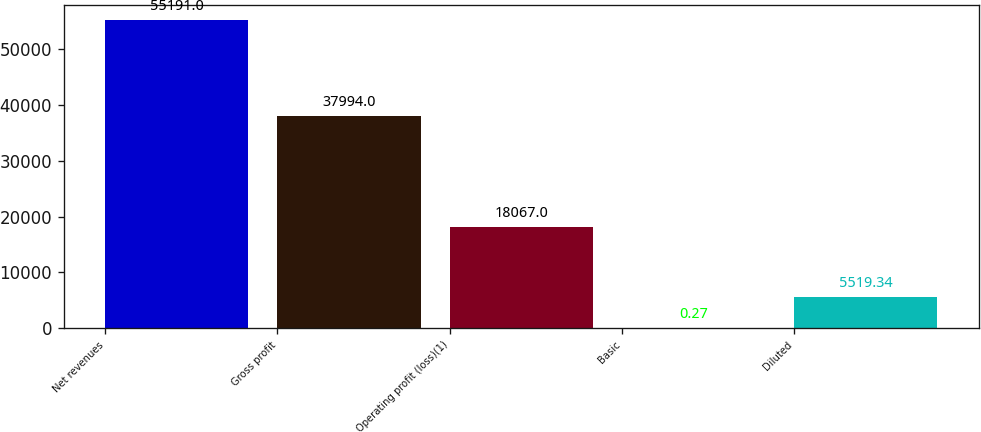Convert chart to OTSL. <chart><loc_0><loc_0><loc_500><loc_500><bar_chart><fcel>Net revenues<fcel>Gross profit<fcel>Operating profit (loss)(1)<fcel>Basic<fcel>Diluted<nl><fcel>55191<fcel>37994<fcel>18067<fcel>0.27<fcel>5519.34<nl></chart> 